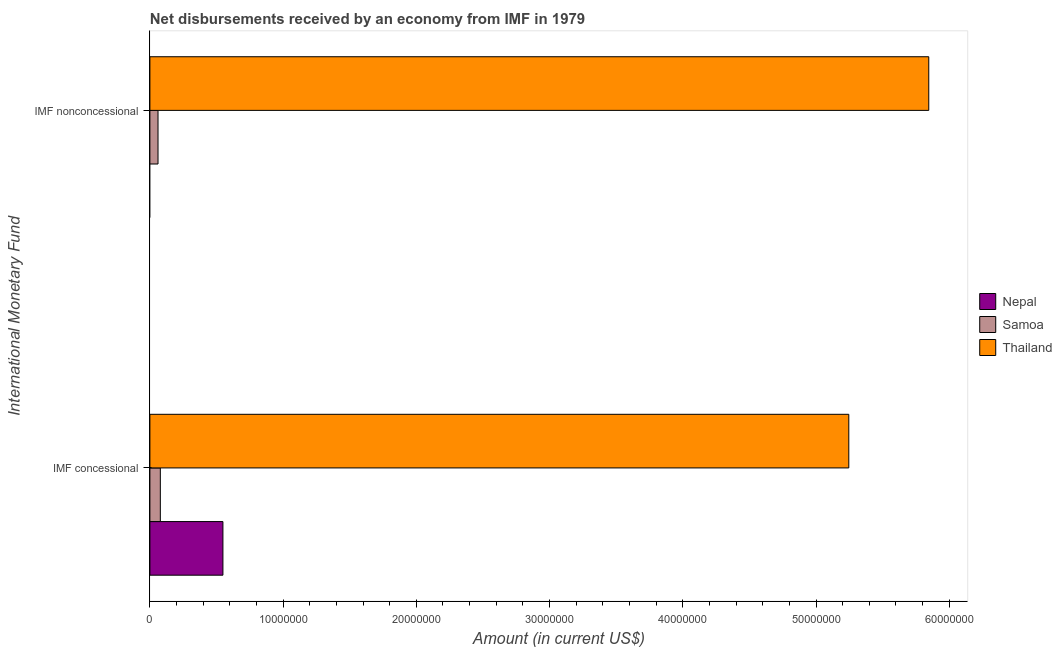How many groups of bars are there?
Ensure brevity in your answer.  2. Are the number of bars on each tick of the Y-axis equal?
Your answer should be compact. No. How many bars are there on the 1st tick from the top?
Make the answer very short. 2. How many bars are there on the 1st tick from the bottom?
Your response must be concise. 3. What is the label of the 2nd group of bars from the top?
Make the answer very short. IMF concessional. What is the net non concessional disbursements from imf in Thailand?
Your answer should be very brief. 5.85e+07. Across all countries, what is the maximum net concessional disbursements from imf?
Ensure brevity in your answer.  5.25e+07. In which country was the net concessional disbursements from imf maximum?
Provide a succinct answer. Thailand. What is the total net concessional disbursements from imf in the graph?
Offer a terse response. 5.87e+07. What is the difference between the net concessional disbursements from imf in Samoa and that in Thailand?
Give a very brief answer. -5.17e+07. What is the difference between the net concessional disbursements from imf in Nepal and the net non concessional disbursements from imf in Thailand?
Keep it short and to the point. -5.30e+07. What is the average net non concessional disbursements from imf per country?
Ensure brevity in your answer.  1.97e+07. What is the difference between the net non concessional disbursements from imf and net concessional disbursements from imf in Thailand?
Provide a short and direct response. 6.00e+06. What is the ratio of the net non concessional disbursements from imf in Thailand to that in Samoa?
Offer a very short reply. 95.84. Is the net concessional disbursements from imf in Thailand less than that in Samoa?
Provide a short and direct response. No. What is the difference between two consecutive major ticks on the X-axis?
Provide a succinct answer. 1.00e+07. Where does the legend appear in the graph?
Provide a succinct answer. Center right. How many legend labels are there?
Provide a succinct answer. 3. What is the title of the graph?
Offer a terse response. Net disbursements received by an economy from IMF in 1979. What is the label or title of the X-axis?
Make the answer very short. Amount (in current US$). What is the label or title of the Y-axis?
Your answer should be very brief. International Monetary Fund. What is the Amount (in current US$) of Nepal in IMF concessional?
Offer a terse response. 5.48e+06. What is the Amount (in current US$) of Samoa in IMF concessional?
Your answer should be compact. 7.83e+05. What is the Amount (in current US$) of Thailand in IMF concessional?
Make the answer very short. 5.25e+07. What is the Amount (in current US$) of Nepal in IMF nonconcessional?
Provide a succinct answer. 0. What is the Amount (in current US$) in Samoa in IMF nonconcessional?
Offer a very short reply. 6.10e+05. What is the Amount (in current US$) of Thailand in IMF nonconcessional?
Your answer should be very brief. 5.85e+07. Across all International Monetary Fund, what is the maximum Amount (in current US$) in Nepal?
Ensure brevity in your answer.  5.48e+06. Across all International Monetary Fund, what is the maximum Amount (in current US$) of Samoa?
Make the answer very short. 7.83e+05. Across all International Monetary Fund, what is the maximum Amount (in current US$) of Thailand?
Provide a short and direct response. 5.85e+07. Across all International Monetary Fund, what is the minimum Amount (in current US$) in Samoa?
Give a very brief answer. 6.10e+05. Across all International Monetary Fund, what is the minimum Amount (in current US$) in Thailand?
Make the answer very short. 5.25e+07. What is the total Amount (in current US$) of Nepal in the graph?
Your answer should be compact. 5.48e+06. What is the total Amount (in current US$) of Samoa in the graph?
Your answer should be very brief. 1.39e+06. What is the total Amount (in current US$) of Thailand in the graph?
Offer a very short reply. 1.11e+08. What is the difference between the Amount (in current US$) in Samoa in IMF concessional and that in IMF nonconcessional?
Give a very brief answer. 1.73e+05. What is the difference between the Amount (in current US$) of Thailand in IMF concessional and that in IMF nonconcessional?
Provide a succinct answer. -6.00e+06. What is the difference between the Amount (in current US$) in Nepal in IMF concessional and the Amount (in current US$) in Samoa in IMF nonconcessional?
Your answer should be compact. 4.87e+06. What is the difference between the Amount (in current US$) in Nepal in IMF concessional and the Amount (in current US$) in Thailand in IMF nonconcessional?
Offer a very short reply. -5.30e+07. What is the difference between the Amount (in current US$) of Samoa in IMF concessional and the Amount (in current US$) of Thailand in IMF nonconcessional?
Provide a short and direct response. -5.77e+07. What is the average Amount (in current US$) in Nepal per International Monetary Fund?
Provide a succinct answer. 2.74e+06. What is the average Amount (in current US$) of Samoa per International Monetary Fund?
Make the answer very short. 6.96e+05. What is the average Amount (in current US$) in Thailand per International Monetary Fund?
Your answer should be very brief. 5.55e+07. What is the difference between the Amount (in current US$) of Nepal and Amount (in current US$) of Samoa in IMF concessional?
Offer a terse response. 4.70e+06. What is the difference between the Amount (in current US$) of Nepal and Amount (in current US$) of Thailand in IMF concessional?
Ensure brevity in your answer.  -4.70e+07. What is the difference between the Amount (in current US$) in Samoa and Amount (in current US$) in Thailand in IMF concessional?
Provide a succinct answer. -5.17e+07. What is the difference between the Amount (in current US$) of Samoa and Amount (in current US$) of Thailand in IMF nonconcessional?
Provide a succinct answer. -5.79e+07. What is the ratio of the Amount (in current US$) of Samoa in IMF concessional to that in IMF nonconcessional?
Your response must be concise. 1.28. What is the ratio of the Amount (in current US$) of Thailand in IMF concessional to that in IMF nonconcessional?
Give a very brief answer. 0.9. What is the difference between the highest and the second highest Amount (in current US$) in Samoa?
Your answer should be very brief. 1.73e+05. What is the difference between the highest and the second highest Amount (in current US$) in Thailand?
Offer a terse response. 6.00e+06. What is the difference between the highest and the lowest Amount (in current US$) in Nepal?
Make the answer very short. 5.48e+06. What is the difference between the highest and the lowest Amount (in current US$) in Samoa?
Give a very brief answer. 1.73e+05. What is the difference between the highest and the lowest Amount (in current US$) in Thailand?
Your answer should be compact. 6.00e+06. 